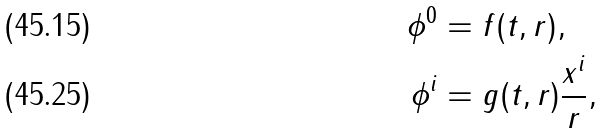Convert formula to latex. <formula><loc_0><loc_0><loc_500><loc_500>\phi ^ { 0 } & = f ( t , r ) , \\ \phi ^ { i } & = g ( t , r ) \frac { x ^ { i } } { r } ,</formula> 